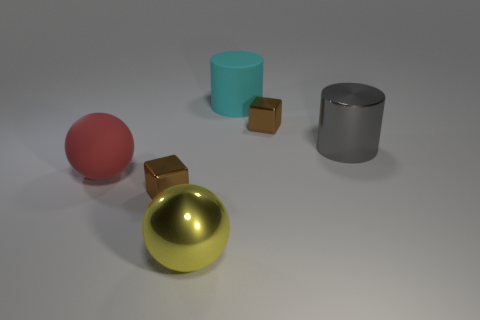How many other things are the same color as the rubber cylinder?
Keep it short and to the point. 0. Is the number of shiny cubes on the left side of the metal sphere less than the number of red balls that are behind the red rubber ball?
Ensure brevity in your answer.  No. Do the big gray metallic object and the red matte thing have the same shape?
Offer a terse response. No. What number of brown cylinders are the same size as the yellow object?
Give a very brief answer. 0. Is the number of yellow metal things that are behind the big matte cylinder less than the number of big red balls?
Ensure brevity in your answer.  Yes. What size is the block that is behind the brown object that is to the left of the big cyan cylinder?
Your answer should be compact. Small. What number of objects are either small metal cylinders or metallic things?
Your answer should be very brief. 4. Is there a large object of the same color as the metal cylinder?
Offer a very short reply. No. Is the number of small brown objects less than the number of small cyan matte cylinders?
Offer a very short reply. No. What number of objects are brown objects or tiny objects that are right of the big yellow ball?
Give a very brief answer. 2. 